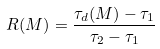<formula> <loc_0><loc_0><loc_500><loc_500>R ( M ) = \frac { \tau _ { d } ( M ) - \tau _ { 1 } } { \tau _ { 2 } - \tau _ { 1 } }</formula> 